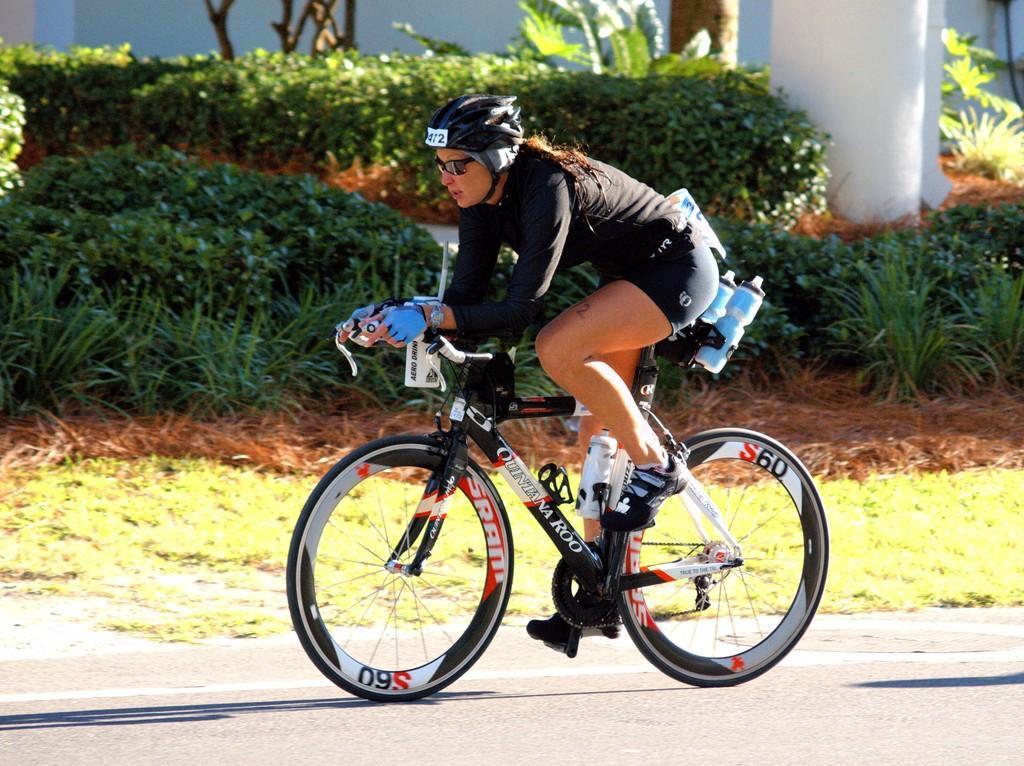Please provide a concise description of this image. In this picture we can see a woman wore a helmet, goggles, shoes, gloves and riding a bicycle on the road and in the background we can see trees. 